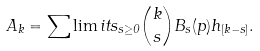Convert formula to latex. <formula><loc_0><loc_0><loc_500><loc_500>A _ { k } = \sum \lim i t s _ { s \geq 0 } \binom { k } { s } B _ { s } ( p ) h _ { [ k - s ] } .</formula> 